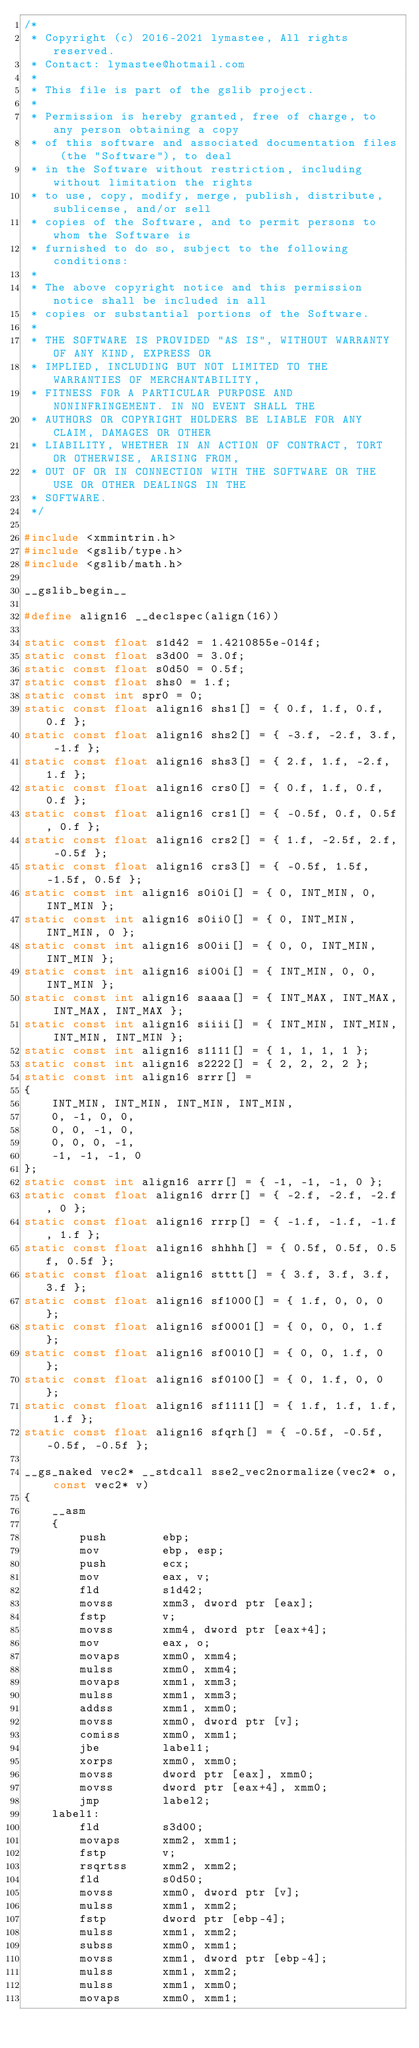Convert code to text. <code><loc_0><loc_0><loc_500><loc_500><_C++_>/*
 * Copyright (c) 2016-2021 lymastee, All rights reserved.
 * Contact: lymastee@hotmail.com
 *
 * This file is part of the gslib project.
 * 
 * Permission is hereby granted, free of charge, to any person obtaining a copy
 * of this software and associated documentation files (the "Software"), to deal
 * in the Software without restriction, including without limitation the rights
 * to use, copy, modify, merge, publish, distribute, sublicense, and/or sell
 * copies of the Software, and to permit persons to whom the Software is
 * furnished to do so, subject to the following conditions:
 * 
 * The above copyright notice and this permission notice shall be included in all
 * copies or substantial portions of the Software.
 * 
 * THE SOFTWARE IS PROVIDED "AS IS", WITHOUT WARRANTY OF ANY KIND, EXPRESS OR
 * IMPLIED, INCLUDING BUT NOT LIMITED TO THE WARRANTIES OF MERCHANTABILITY,
 * FITNESS FOR A PARTICULAR PURPOSE AND NONINFRINGEMENT. IN NO EVENT SHALL THE
 * AUTHORS OR COPYRIGHT HOLDERS BE LIABLE FOR ANY CLAIM, DAMAGES OR OTHER
 * LIABILITY, WHETHER IN AN ACTION OF CONTRACT, TORT OR OTHERWISE, ARISING FROM,
 * OUT OF OR IN CONNECTION WITH THE SOFTWARE OR THE USE OR OTHER DEALINGS IN THE
 * SOFTWARE.
 */

#include <xmmintrin.h>
#include <gslib/type.h>
#include <gslib/math.h>

__gslib_begin__

#define align16 __declspec(align(16))

static const float s1d42 = 1.4210855e-014f;
static const float s3d00 = 3.0f;
static const float s0d50 = 0.5f;
static const float shs0 = 1.f;
static const int spr0 = 0;
static const float align16 shs1[] = { 0.f, 1.f, 0.f, 0.f };
static const float align16 shs2[] = { -3.f, -2.f, 3.f, -1.f };
static const float align16 shs3[] = { 2.f, 1.f, -2.f, 1.f };
static const float align16 crs0[] = { 0.f, 1.f, 0.f, 0.f };
static const float align16 crs1[] = { -0.5f, 0.f, 0.5f, 0.f };
static const float align16 crs2[] = { 1.f, -2.5f, 2.f, -0.5f };
static const float align16 crs3[] = { -0.5f, 1.5f, -1.5f, 0.5f };
static const int align16 s0i0i[] = { 0, INT_MIN, 0, INT_MIN };
static const int align16 s0ii0[] = { 0, INT_MIN, INT_MIN, 0 };
static const int align16 s00ii[] = { 0, 0, INT_MIN, INT_MIN };
static const int align16 si00i[] = { INT_MIN, 0, 0, INT_MIN };
static const int align16 saaaa[] = { INT_MAX, INT_MAX, INT_MAX, INT_MAX };
static const int align16 siiii[] = { INT_MIN, INT_MIN, INT_MIN, INT_MIN };
static const int align16 s1111[] = { 1, 1, 1, 1 };
static const int align16 s2222[] = { 2, 2, 2, 2 };
static const int align16 srrr[] =
{
    INT_MIN, INT_MIN, INT_MIN, INT_MIN,
    0, -1, 0, 0,
    0, 0, -1, 0,
    0, 0, 0, -1,
    -1, -1, -1, 0
};
static const int align16 arrr[] = { -1, -1, -1, 0 };
static const float align16 drrr[] = { -2.f, -2.f, -2.f, 0 };
static const float align16 rrrp[] = { -1.f, -1.f, -1.f, 1.f };
static const float align16 shhhh[] = { 0.5f, 0.5f, 0.5f, 0.5f };
static const float align16 stttt[] = { 3.f, 3.f, 3.f, 3.f };
static const float align16 sf1000[] = { 1.f, 0, 0, 0 };
static const float align16 sf0001[] = { 0, 0, 0, 1.f };
static const float align16 sf0010[] = { 0, 0, 1.f, 0 };
static const float align16 sf0100[] = { 0, 1.f, 0, 0 };
static const float align16 sf1111[] = { 1.f, 1.f, 1.f, 1.f };
static const float align16 sfqrh[] = { -0.5f, -0.5f, -0.5f, -0.5f };

__gs_naked vec2* __stdcall sse2_vec2normalize(vec2* o, const vec2* v)
{
    __asm
    {
        push        ebp;
        mov         ebp, esp;
        push        ecx;
        mov         eax, v;
        fld         s1d42;
        movss       xmm3, dword ptr [eax];
        fstp        v;
        movss       xmm4, dword ptr [eax+4];
        mov         eax, o;
        movaps      xmm0, xmm4;
        mulss       xmm0, xmm4;
        movaps      xmm1, xmm3;
        mulss       xmm1, xmm3;
        addss       xmm1, xmm0;
        movss       xmm0, dword ptr [v];
        comiss      xmm0, xmm1;
        jbe         label1;
        xorps       xmm0, xmm0;
        movss       dword ptr [eax], xmm0;
        movss       dword ptr [eax+4], xmm0;
        jmp         label2;
    label1:
        fld         s3d00;
        movaps      xmm2, xmm1;
        fstp        v;
        rsqrtss     xmm2, xmm2;
        fld         s0d50;
        movss       xmm0, dword ptr [v];
        mulss       xmm1, xmm2;
        fstp        dword ptr [ebp-4];
        mulss       xmm1, xmm2;
        subss       xmm0, xmm1;
        movss       xmm1, dword ptr [ebp-4];
        mulss       xmm1, xmm2;
        mulss       xmm1, xmm0;
        movaps      xmm0, xmm1;</code> 